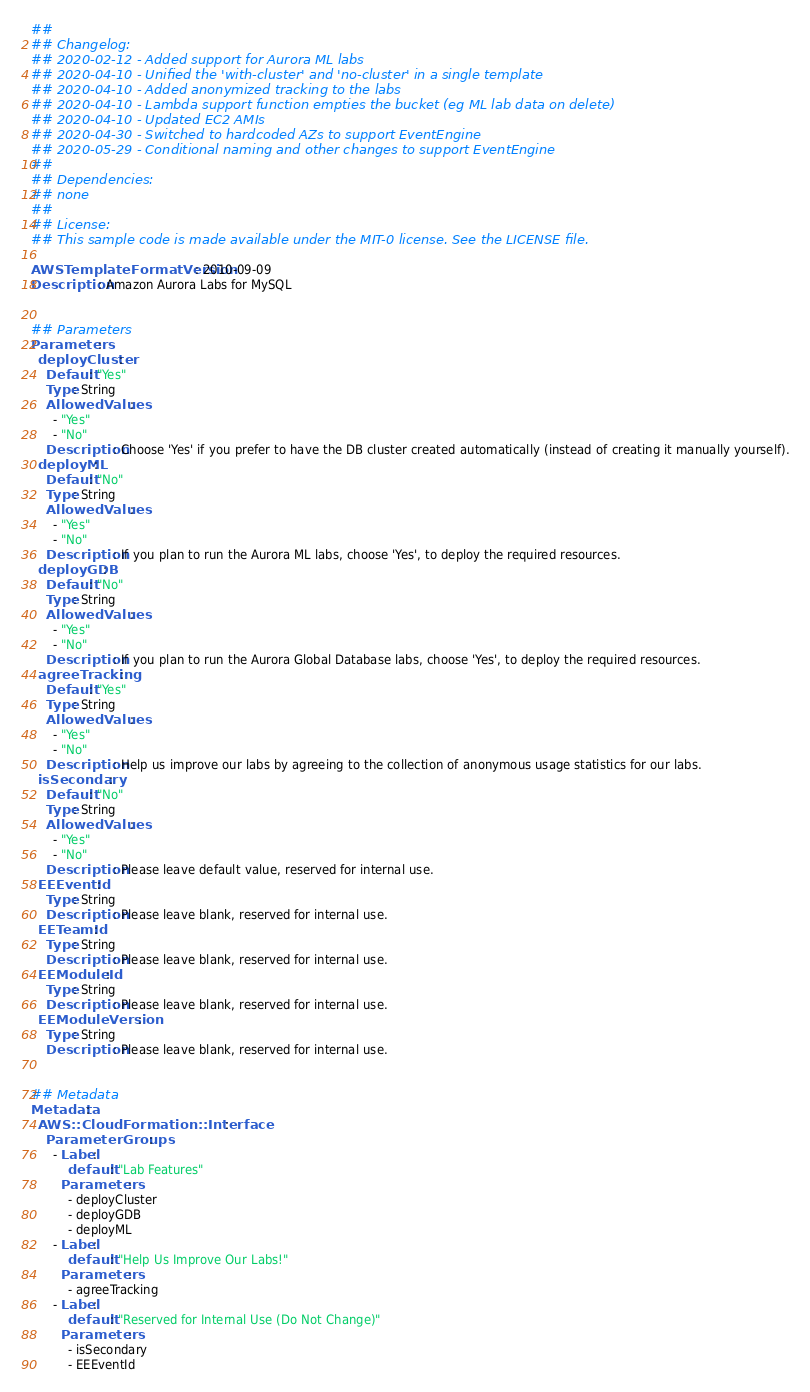Convert code to text. <code><loc_0><loc_0><loc_500><loc_500><_YAML_>##
## Changelog:
## 2020-02-12 - Added support for Aurora ML labs
## 2020-04-10 - Unified the 'with-cluster' and 'no-cluster' in a single template
## 2020-04-10 - Added anonymized tracking to the labs
## 2020-04-10 - Lambda support function empties the bucket (eg ML lab data on delete)
## 2020-04-10 - Updated EC2 AMIs
## 2020-04-30 - Switched to hardcoded AZs to support EventEngine
## 2020-05-29 - Conditional naming and other changes to support EventEngine
##
## Dependencies:
## none
##
## License:
## This sample code is made available under the MIT-0 license. See the LICENSE file.

AWSTemplateFormatVersion: 2010-09-09
Description: Amazon Aurora Labs for MySQL


## Parameters
Parameters:
  deployCluster:
    Default: "Yes"
    Type: String
    AllowedValues:
      - "Yes"
      - "No"
    Description: Choose 'Yes' if you prefer to have the DB cluster created automatically (instead of creating it manually yourself).
  deployML:
    Default: "No"
    Type: String
    AllowedValues:
      - "Yes"
      - "No"
    Description: If you plan to run the Aurora ML labs, choose 'Yes', to deploy the required resources.
  deployGDB:
    Default: "No"
    Type: String
    AllowedValues:
      - "Yes"
      - "No"
    Description: If you plan to run the Aurora Global Database labs, choose 'Yes', to deploy the required resources.
  agreeTracking:
    Default: "Yes"
    Type: String
    AllowedValues:
      - "Yes"
      - "No"
    Description: Help us improve our labs by agreeing to the collection of anonymous usage statistics for our labs.
  isSecondary:
    Default: "No"
    Type: String
    AllowedValues:
      - "Yes"
      - "No"
    Description: Please leave default value, reserved for internal use.
  EEEventId:
    Type: String
    Description: Please leave blank, reserved for internal use.
  EETeamId:
    Type: String
    Description: Please leave blank, reserved for internal use.
  EEModuleId:
    Type: String
    Description: Please leave blank, reserved for internal use.
  EEModuleVersion:
    Type: String
    Description: Please leave blank, reserved for internal use.


## Metadata
Metadata:
  AWS::CloudFormation::Interface:
    ParameterGroups:
      - Label:
          default: "Lab Features"
        Parameters:
          - deployCluster
          - deployGDB
          - deployML
      - Label:
          default: "Help Us Improve Our Labs!"
        Parameters:
          - agreeTracking
      - Label:
          default: "Reserved for Internal Use (Do Not Change)"
        Parameters:
          - isSecondary
          - EEEventId</code> 